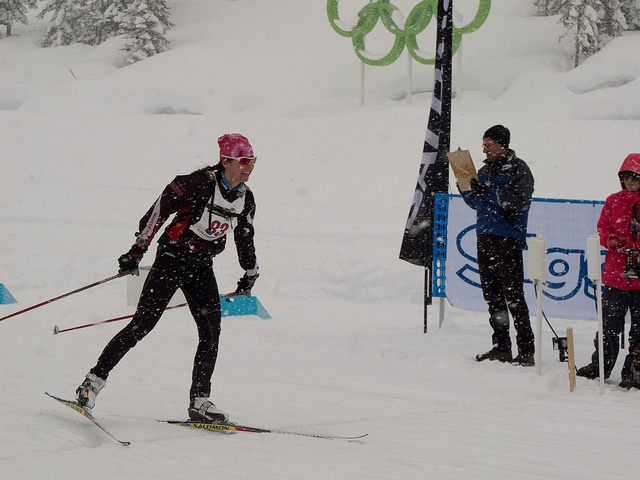Describe the objects in this image and their specific colors. I can see people in gray, black, darkgray, and maroon tones, people in gray, black, and darkgray tones, people in gray, black, maroon, and brown tones, and skis in gray, darkgray, black, and olive tones in this image. 